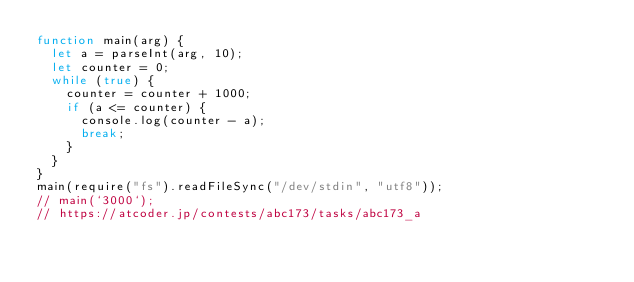Convert code to text. <code><loc_0><loc_0><loc_500><loc_500><_JavaScript_>function main(arg) {
  let a = parseInt(arg, 10);
  let counter = 0;
  while (true) {
    counter = counter + 1000;
    if (a <= counter) {
      console.log(counter - a);
      break;
    }
  }
}
main(require("fs").readFileSync("/dev/stdin", "utf8"));
// main(`3000`);
// https://atcoder.jp/contests/abc173/tasks/abc173_a
</code> 